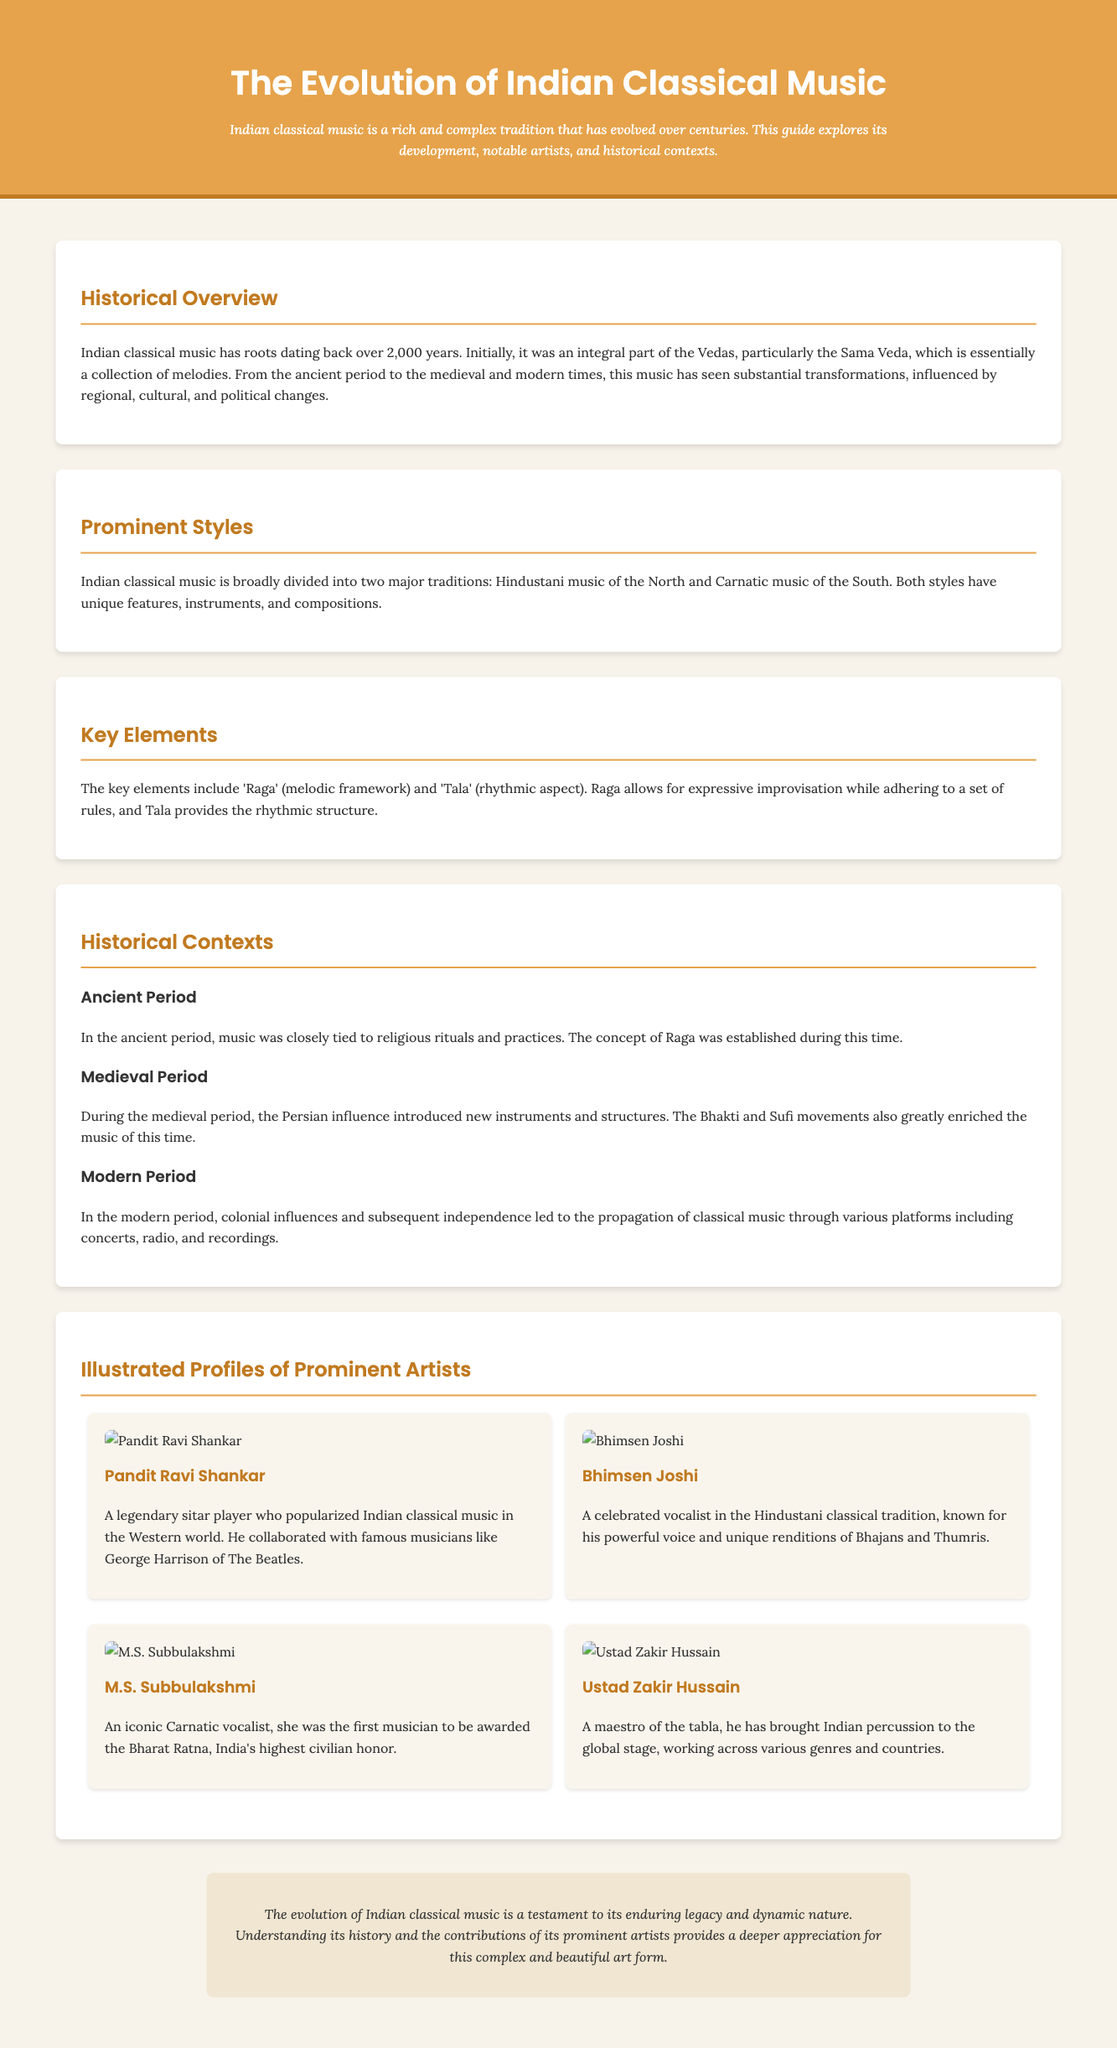What are the two major traditions of Indian classical music? The document states that Indian classical music is broadly divided into Hindustani music and Carnatic music.
Answer: Hindustani and Carnatic Who is known for popularizing Indian classical music in the Western world? The document mentions that Pandit Ravi Shankar is a legendary sitar player who popularized Indian classical music in the Western world.
Answer: Pandit Ravi Shankar What is the Bharat Ratna? The document describes the Bharat Ratna as India's highest civilian honor awarded to M.S. Subbulakshmi, an iconic Carnatic vocalist.
Answer: India's highest civilian honor In which historical period was the concept of Raga established? According to the document, the concept of Raga was established during the ancient period of Indian classical music.
Answer: Ancient Period What instrument is Ustad Zakir Hussain a maestro of? The document states that Ustad Zakir Hussain is a maestro of the tabla.
Answer: Tabla Which two influences enriched music during the medieval period? The document states that the Bhakti and Sufi movements greatly enriched music during the medieval period.
Answer: Bhakti and Sufi movements What is the primary function of 'Tala' in Indian classical music? The document explains that Tala provides the rhythmic structure in Indian classical music.
Answer: Rhythmic structure How has the evolution of Indian classical music affected its legacy? The document concludes that the evolution of Indian classical music testifies to its enduring legacy and dynamic nature.
Answer: Enduring legacy and dynamic nature What significant change occurred in the modern period regarding classical music? The document mentions that colonial influences and subsequent independence led to the propagation of classical music through various platforms.
Answer: Propagation through various platforms 